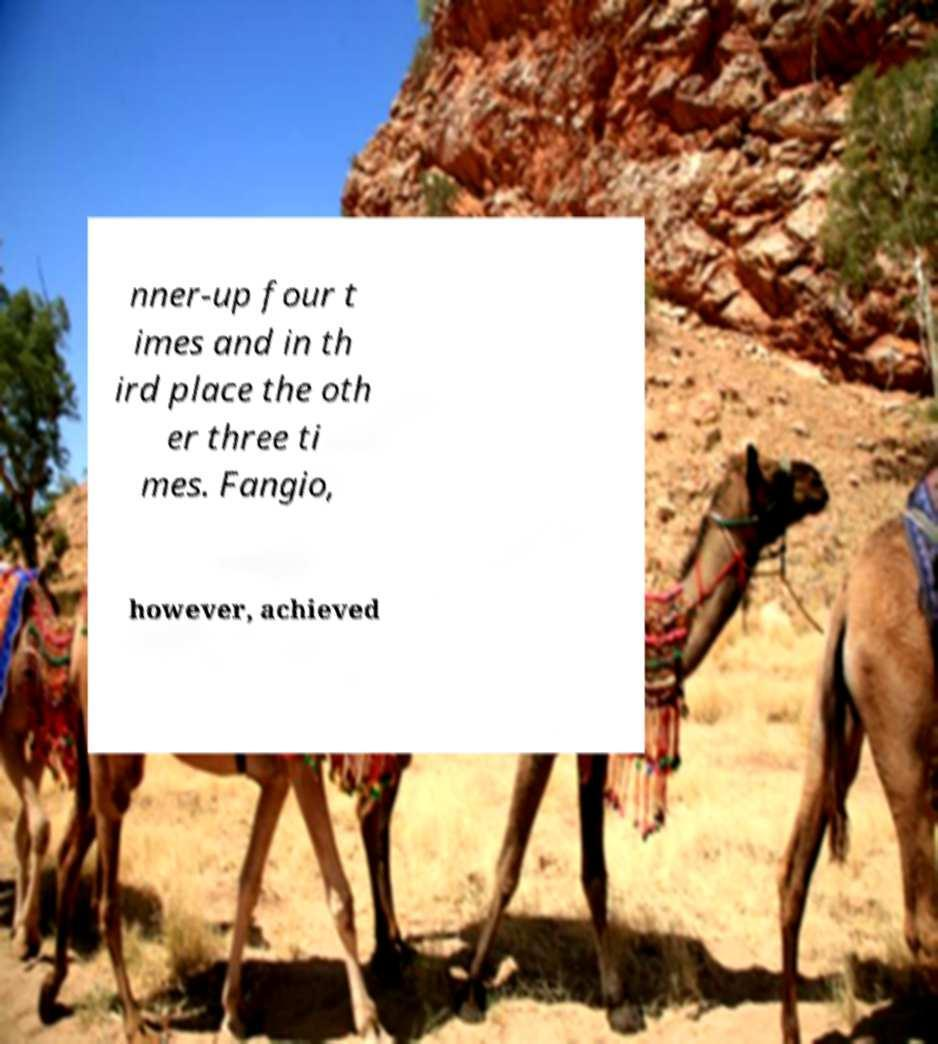Could you assist in decoding the text presented in this image and type it out clearly? nner-up four t imes and in th ird place the oth er three ti mes. Fangio, however, achieved 